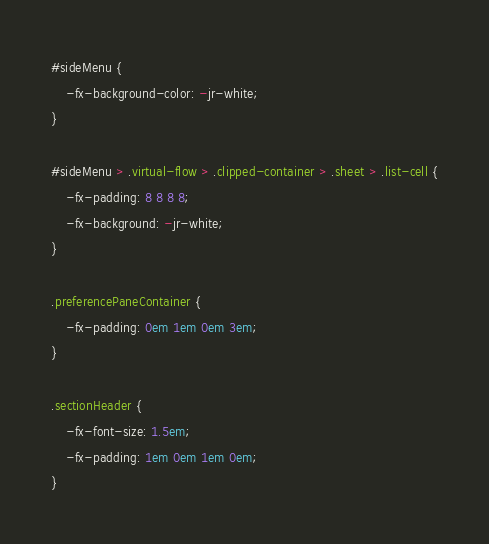Convert code to text. <code><loc_0><loc_0><loc_500><loc_500><_CSS_>#sideMenu {
    -fx-background-color: -jr-white;
}

#sideMenu > .virtual-flow > .clipped-container > .sheet > .list-cell {
    -fx-padding: 8 8 8 8;
    -fx-background: -jr-white;
}

.preferencePaneContainer {
    -fx-padding: 0em 1em 0em 3em;
}

.sectionHeader {
    -fx-font-size: 1.5em;
    -fx-padding: 1em 0em 1em 0em;
}
</code> 